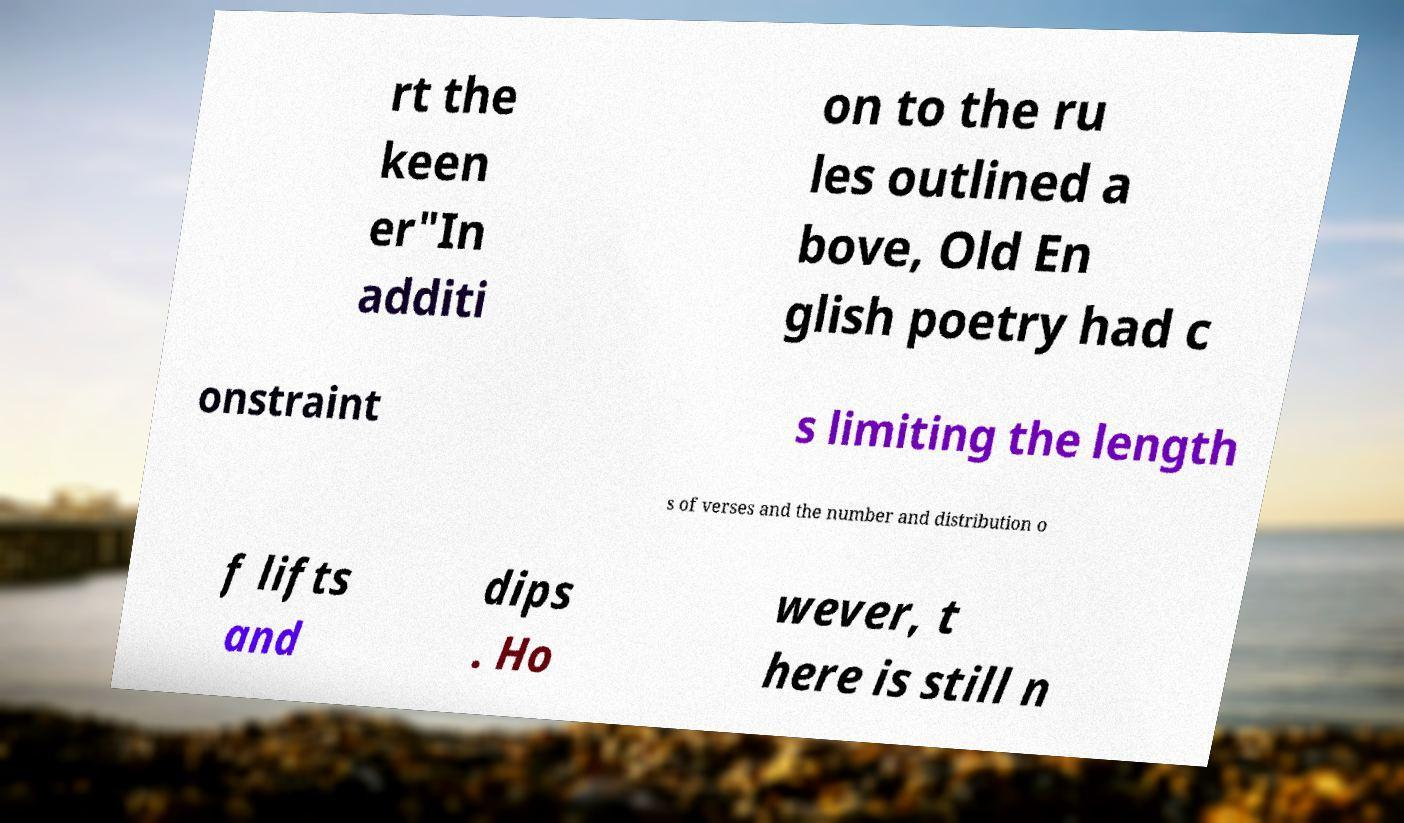I need the written content from this picture converted into text. Can you do that? rt the keen er"In additi on to the ru les outlined a bove, Old En glish poetry had c onstraint s limiting the length s of verses and the number and distribution o f lifts and dips . Ho wever, t here is still n 